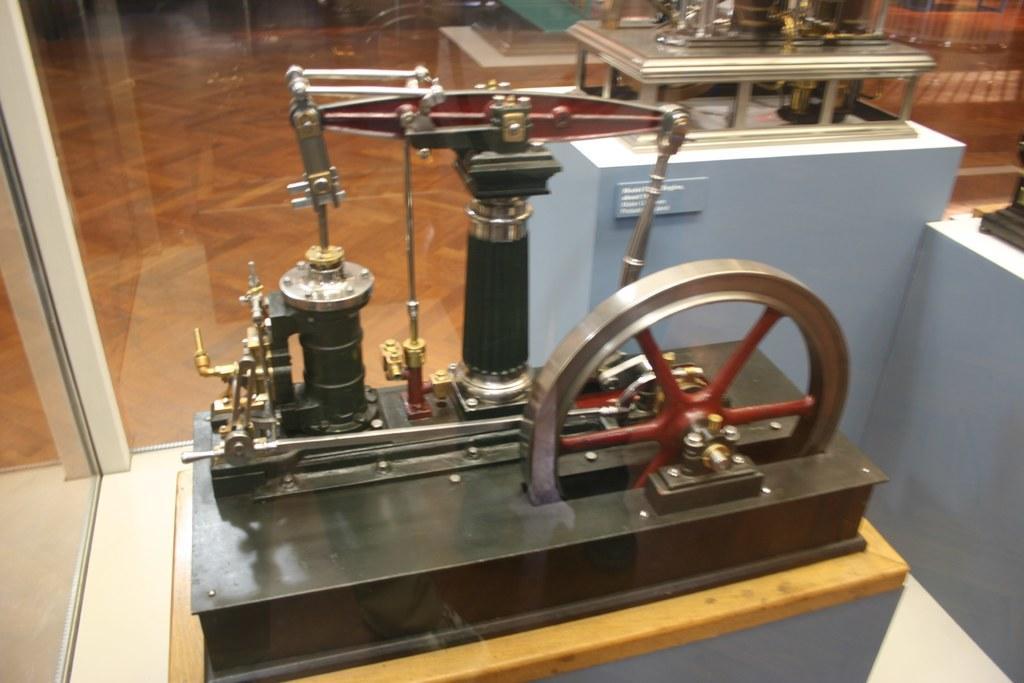Describe this image in one or two sentences. In the image there is a machinery in a glass box, this seems to be in a museum. 